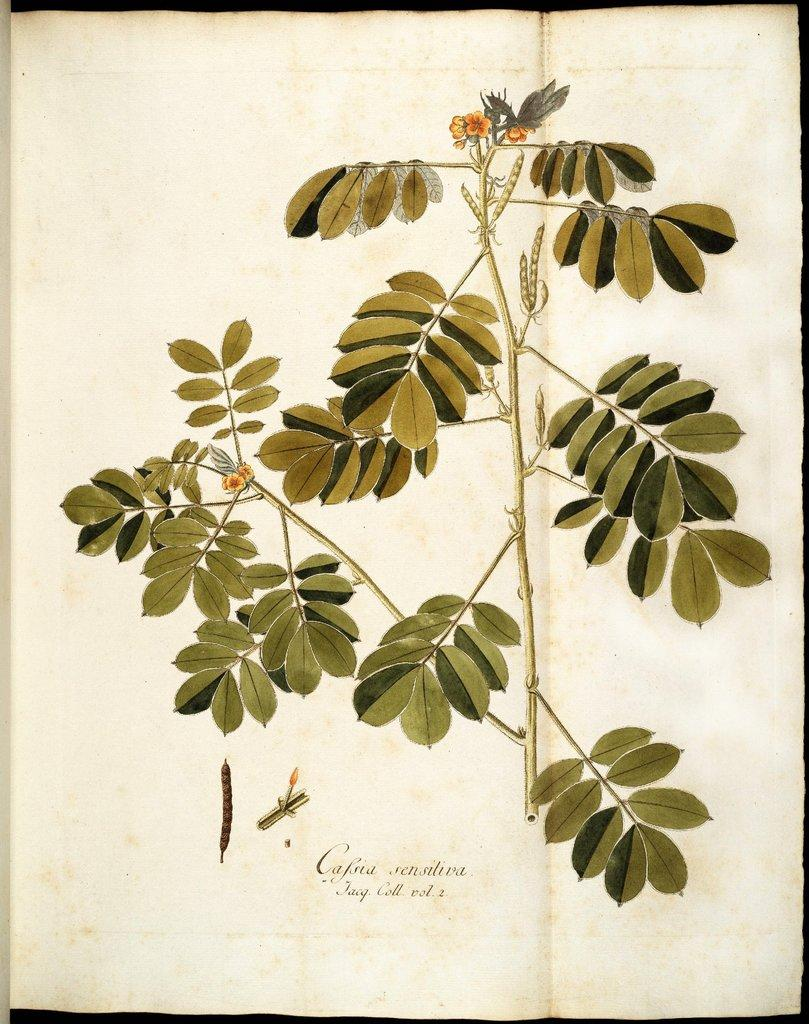What is the main subject of the paper in the image? The main subject of the paper is a plant. Can you describe the plant in the image? The plant has stems, green leaves, flowers, and beans. What is the color of the plant's leaves? The plant's leaves are green. What else is present on the paper besides the image of the plant? There is text on the paper. How many eyes can be seen on the plant in the image? There are no eyes present on the plant in the image, as plants do not have eyes. What type of trees are visible in the background of the image? There are no trees visible in the image; it only contains a paper with an image of a plant. 